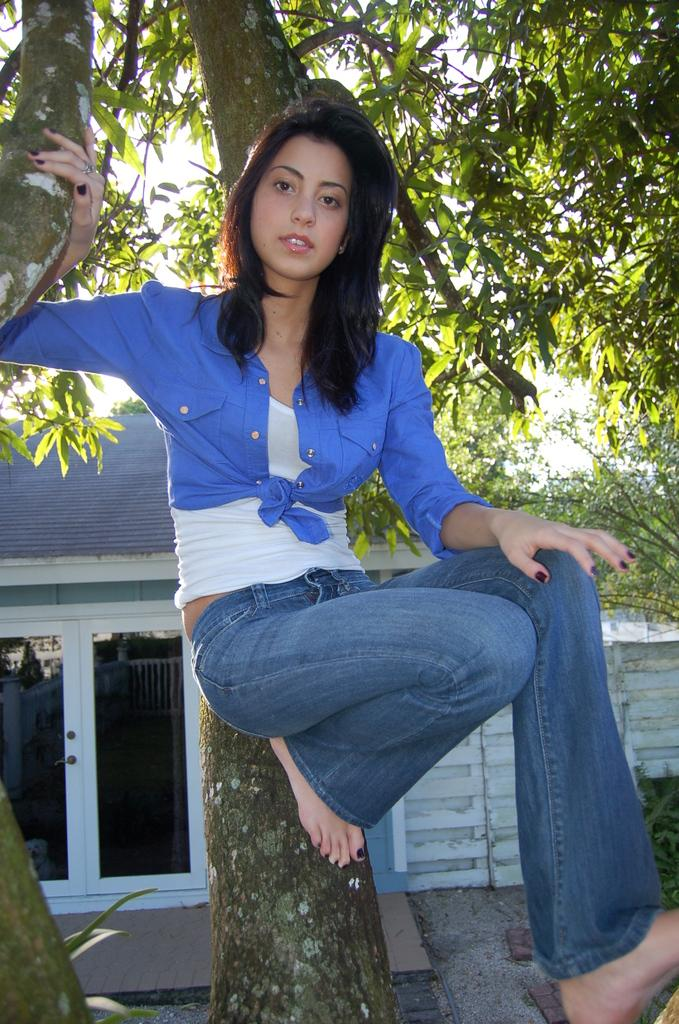Who is in the image? There is a woman in the image. Where is the woman located? The woman is on a tree branch. What is the woman doing? The woman is watching something. What can be seen in the background of the image? There is a house, glass doors, a walkway, plants, and a tree in the background of the image. What type of prose is the woman attempting to write on the tree branch? There is no indication in the image that the woman is attempting to write any prose, as she is simply watching something. 